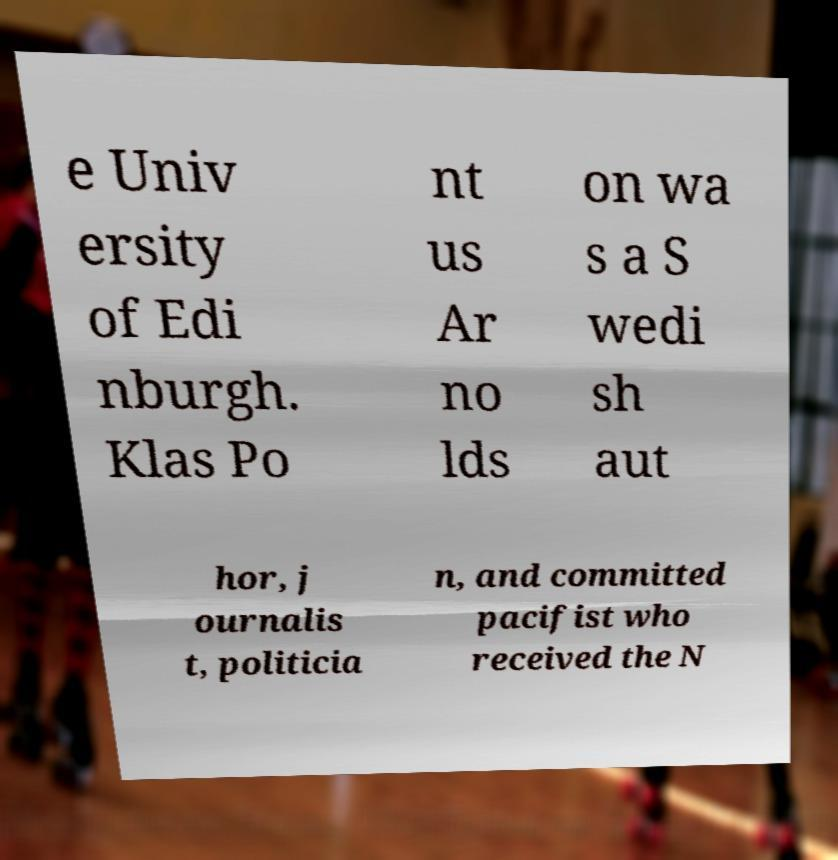Could you extract and type out the text from this image? e Univ ersity of Edi nburgh. Klas Po nt us Ar no lds on wa s a S wedi sh aut hor, j ournalis t, politicia n, and committed pacifist who received the N 